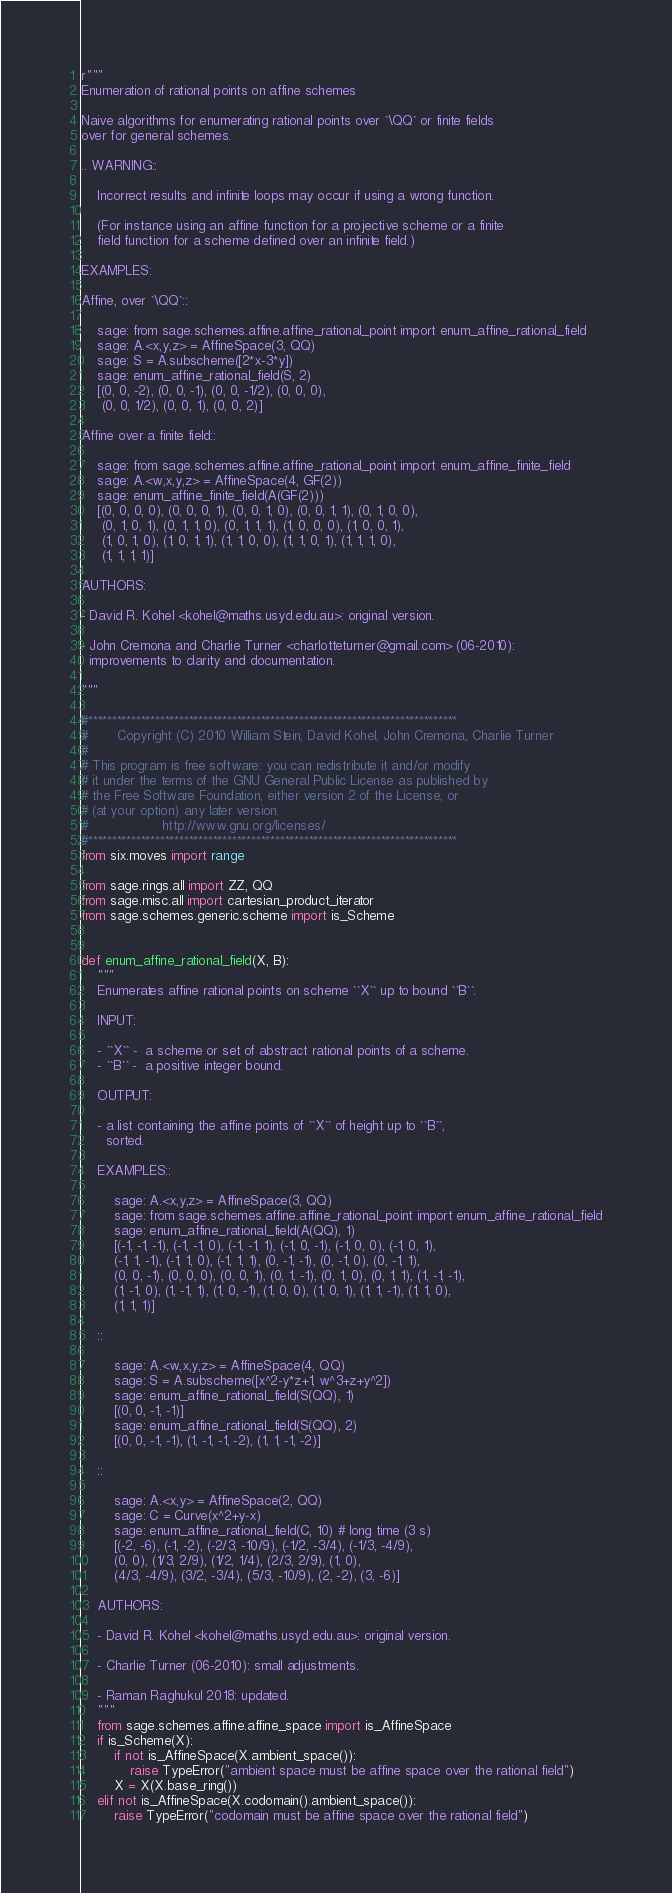Convert code to text. <code><loc_0><loc_0><loc_500><loc_500><_Python_>r"""
Enumeration of rational points on affine schemes

Naive algorithms for enumerating rational points over `\QQ` or finite fields
over for general schemes.

.. WARNING::

    Incorrect results and infinite loops may occur if using a wrong function.

    (For instance using an affine function for a projective scheme or a finite
    field function for a scheme defined over an infinite field.)

EXAMPLES:

Affine, over `\QQ`::

    sage: from sage.schemes.affine.affine_rational_point import enum_affine_rational_field
    sage: A.<x,y,z> = AffineSpace(3, QQ)
    sage: S = A.subscheme([2*x-3*y])
    sage: enum_affine_rational_field(S, 2)
    [(0, 0, -2), (0, 0, -1), (0, 0, -1/2), (0, 0, 0),
     (0, 0, 1/2), (0, 0, 1), (0, 0, 2)]

Affine over a finite field::

    sage: from sage.schemes.affine.affine_rational_point import enum_affine_finite_field
    sage: A.<w,x,y,z> = AffineSpace(4, GF(2))
    sage: enum_affine_finite_field(A(GF(2)))
    [(0, 0, 0, 0), (0, 0, 0, 1), (0, 0, 1, 0), (0, 0, 1, 1), (0, 1, 0, 0),
     (0, 1, 0, 1), (0, 1, 1, 0), (0, 1, 1, 1), (1, 0, 0, 0), (1, 0, 0, 1),
     (1, 0, 1, 0), (1, 0, 1, 1), (1, 1, 0, 0), (1, 1, 0, 1), (1, 1, 1, 0),
     (1, 1, 1, 1)]

AUTHORS:

- David R. Kohel <kohel@maths.usyd.edu.au>: original version.

- John Cremona and Charlie Turner <charlotteturner@gmail.com> (06-2010):
  improvements to clarity and documentation.

"""

#*****************************************************************************
#       Copyright (C) 2010 William Stein, David Kohel, John Cremona, Charlie Turner
#
# This program is free software: you can redistribute it and/or modify
# it under the terms of the GNU General Public License as published by
# the Free Software Foundation, either version 2 of the License, or
# (at your option) any later version.
#                  http://www.gnu.org/licenses/
#*****************************************************************************
from six.moves import range

from sage.rings.all import ZZ, QQ
from sage.misc.all import cartesian_product_iterator
from sage.schemes.generic.scheme import is_Scheme


def enum_affine_rational_field(X, B):
    """
    Enumerates affine rational points on scheme ``X`` up to bound ``B``.

    INPUT:

    - ``X`` -  a scheme or set of abstract rational points of a scheme.
    - ``B`` -  a positive integer bound.

    OUTPUT:

    - a list containing the affine points of ``X`` of height up to ``B``,
      sorted.

    EXAMPLES::

        sage: A.<x,y,z> = AffineSpace(3, QQ)
        sage: from sage.schemes.affine.affine_rational_point import enum_affine_rational_field
        sage: enum_affine_rational_field(A(QQ), 1)
        [(-1, -1, -1), (-1, -1, 0), (-1, -1, 1), (-1, 0, -1), (-1, 0, 0), (-1, 0, 1),
        (-1, 1, -1), (-1, 1, 0), (-1, 1, 1), (0, -1, -1), (0, -1, 0), (0, -1, 1),
        (0, 0, -1), (0, 0, 0), (0, 0, 1), (0, 1, -1), (0, 1, 0), (0, 1, 1), (1, -1, -1),
        (1, -1, 0), (1, -1, 1), (1, 0, -1), (1, 0, 0), (1, 0, 1), (1, 1, -1), (1, 1, 0),
        (1, 1, 1)]

    ::

        sage: A.<w,x,y,z> = AffineSpace(4, QQ)
        sage: S = A.subscheme([x^2-y*z+1, w^3+z+y^2])
        sage: enum_affine_rational_field(S(QQ), 1)
        [(0, 0, -1, -1)]
        sage: enum_affine_rational_field(S(QQ), 2)
        [(0, 0, -1, -1), (1, -1, -1, -2), (1, 1, -1, -2)]

    ::

        sage: A.<x,y> = AffineSpace(2, QQ)
        sage: C = Curve(x^2+y-x)
        sage: enum_affine_rational_field(C, 10) # long time (3 s)
        [(-2, -6), (-1, -2), (-2/3, -10/9), (-1/2, -3/4), (-1/3, -4/9),
        (0, 0), (1/3, 2/9), (1/2, 1/4), (2/3, 2/9), (1, 0),
        (4/3, -4/9), (3/2, -3/4), (5/3, -10/9), (2, -2), (3, -6)]

    AUTHORS:

    - David R. Kohel <kohel@maths.usyd.edu.au>: original version.

    - Charlie Turner (06-2010): small adjustments.

    - Raman Raghukul 2018: updated.
    """
    from sage.schemes.affine.affine_space import is_AffineSpace
    if is_Scheme(X):
        if not is_AffineSpace(X.ambient_space()):
            raise TypeError("ambient space must be affine space over the rational field")
        X = X(X.base_ring())
    elif not is_AffineSpace(X.codomain().ambient_space()):
        raise TypeError("codomain must be affine space over the rational field")
</code> 